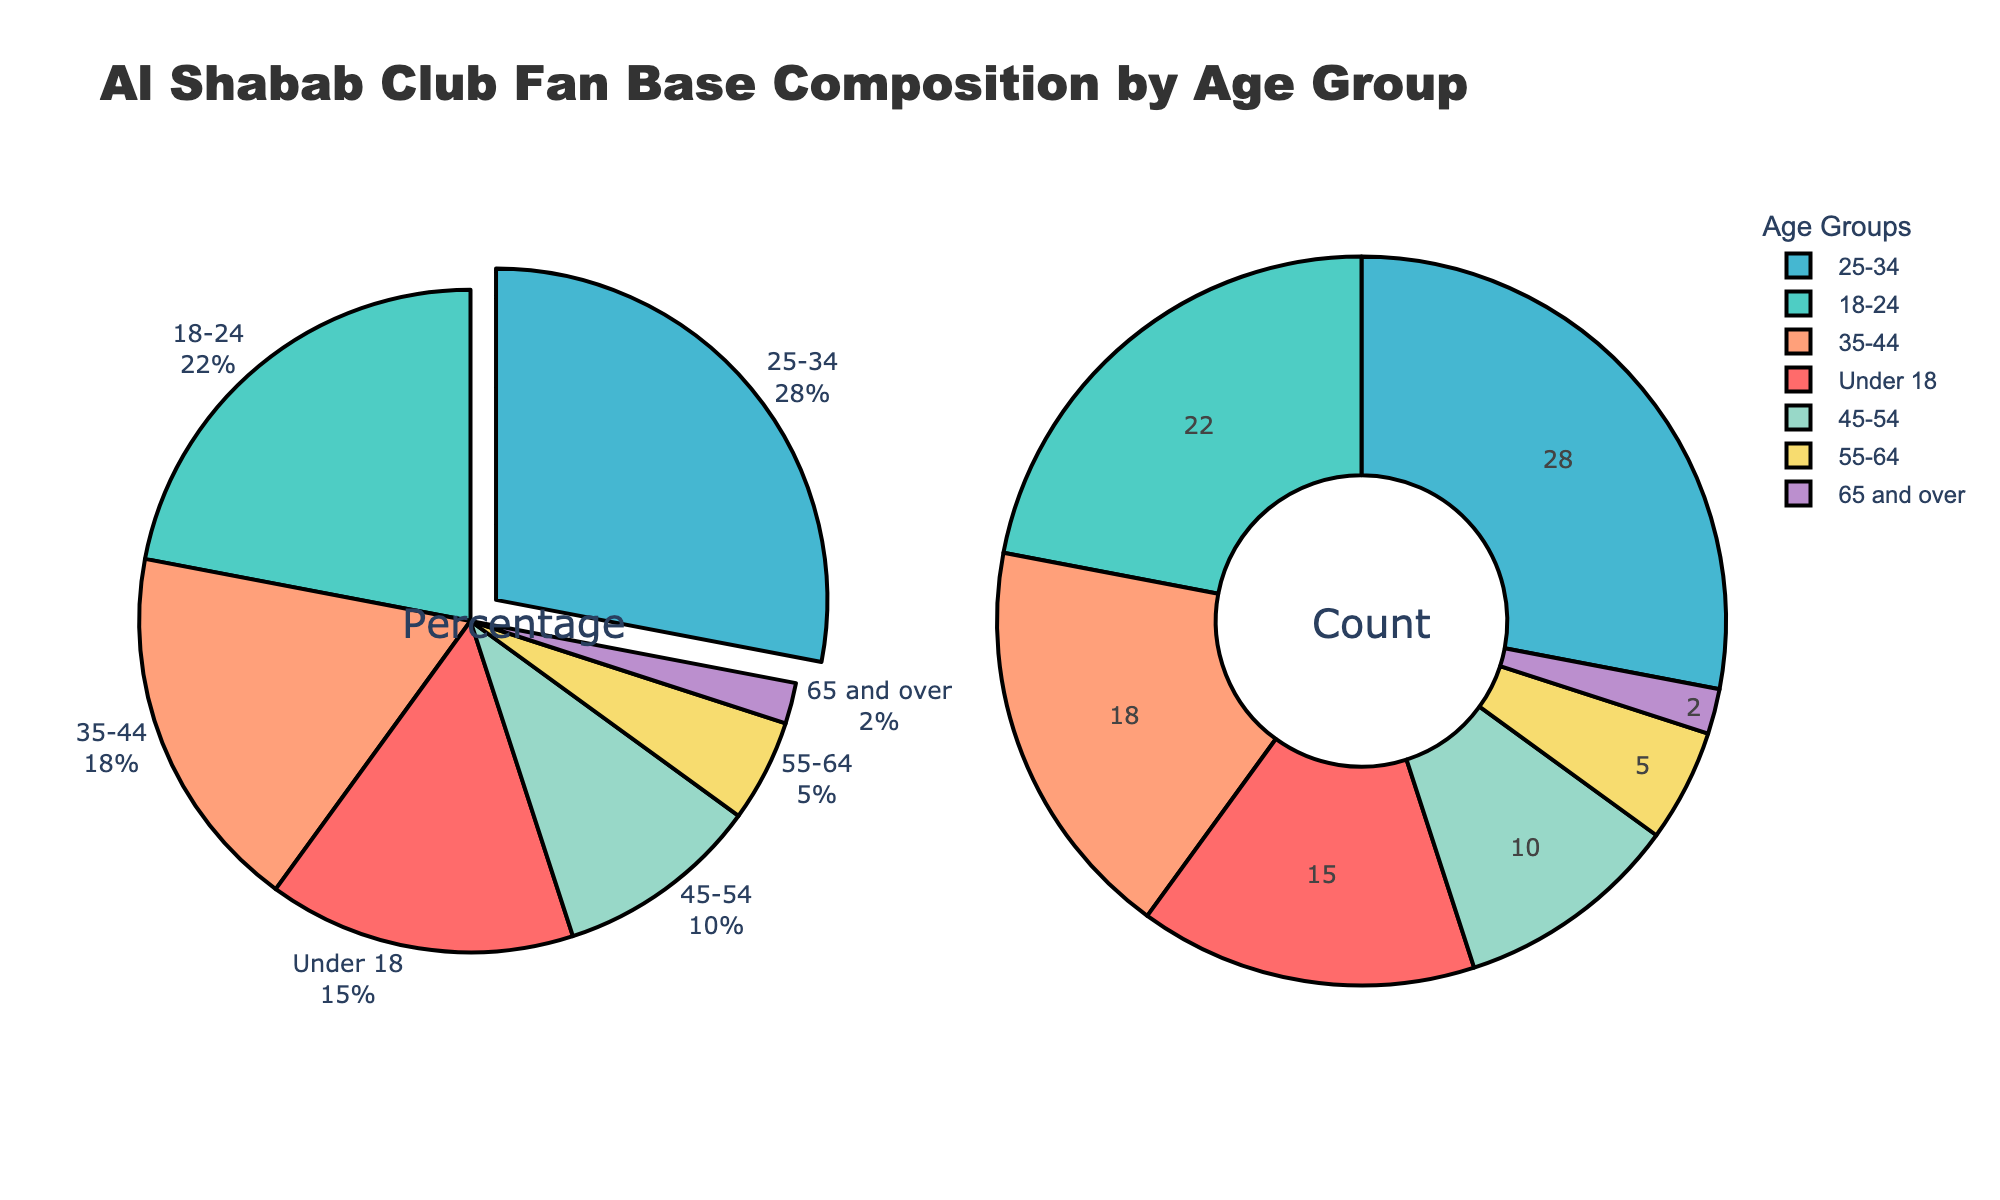What percentage of Al Shabab Club's fan base is aged between 18 and 24? Refer to the pie chart segment labeled "18-24." The percentage value is listed as 22%.
Answer: 22% Which age group makes up the smallest portion of the fan base? Look for the segment with the smallest percentage. The age group labeled "65 and over" shows a 2% share, which is the smallest.
Answer: 65 and over How much larger is the 25-34 age group compared to the 55-64 age group? Find the percentages for both age groups. The 25-34 age group is 28% and the 55-64 group is 5%. The difference is 28% - 5% = 23%.
Answer: 23% What is the combined percentage of fans aged 45 and over? Sum the percentages of the age groups 45-54, 55-64, and 65 and over. These values are 10%, 5%, and 2%, respectively. The combined percentage is 10% + 5% + 2% = 17%.
Answer: 17% Which age group has the largest fan base for Al Shabab Club? Locate the segment with the largest percentage. The age group labeled "25-34" shows a 28% share, which is the largest.
Answer: 25-34 By how much does the percentage of fans aged 35-44 exceed the percentage of fans under 18? Find the percentages for both age groups. The 35-44 age group is 18% and the Under 18 group is 15%. The difference is 18% - 15% = 3%.
Answer: 3% What percentage of Al Shabab Club's fan base is between 18 and 34 years old? Sum the percentages of the age groups 18-24 and 25-34. These values are 22% and 28%, respectively. The combined percentage is 22% + 28% = 50%.
Answer: 50% What distinct visual attribute highlights the segment with the largest percentage in the fan base? Identify visual characteristics of the segment with the largest percentage, 25-34. It is pulled out slightly from the pie chart, indicating it's the largest share.
Answer: Pulled out segment Which color represents the age group with the second-largest fan base? Examine the colors tied to each age group and locate the one with the second-largest percentage (18-24, at 22%). This segment is shown in green.
Answer: Green 